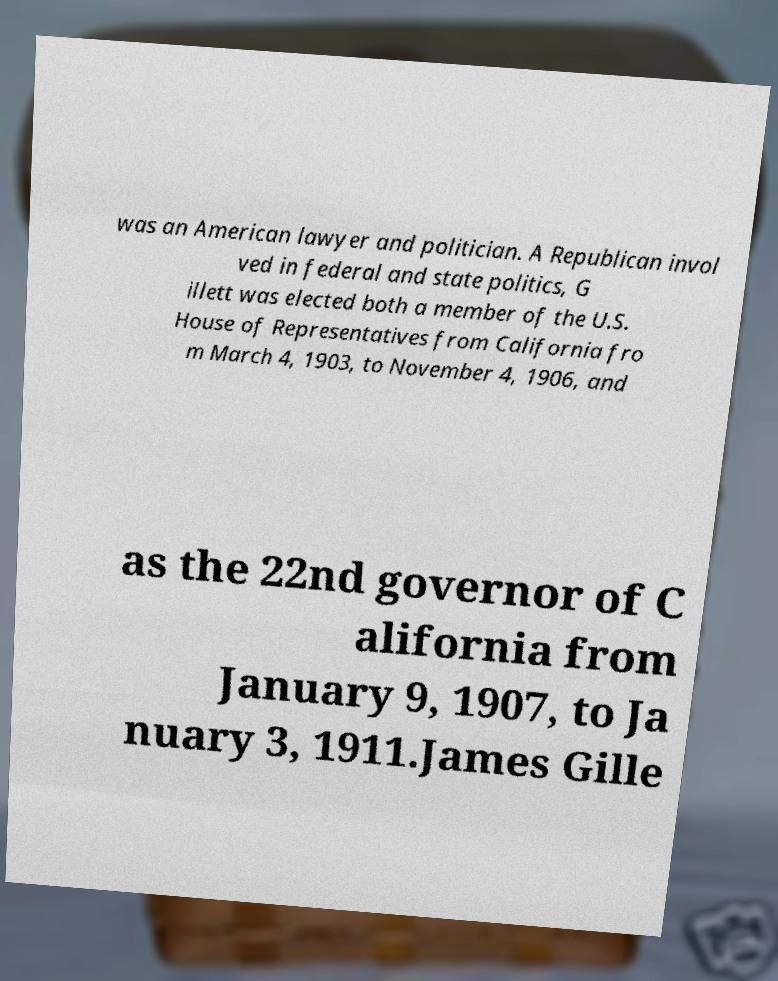Can you accurately transcribe the text from the provided image for me? was an American lawyer and politician. A Republican invol ved in federal and state politics, G illett was elected both a member of the U.S. House of Representatives from California fro m March 4, 1903, to November 4, 1906, and as the 22nd governor of C alifornia from January 9, 1907, to Ja nuary 3, 1911.James Gille 